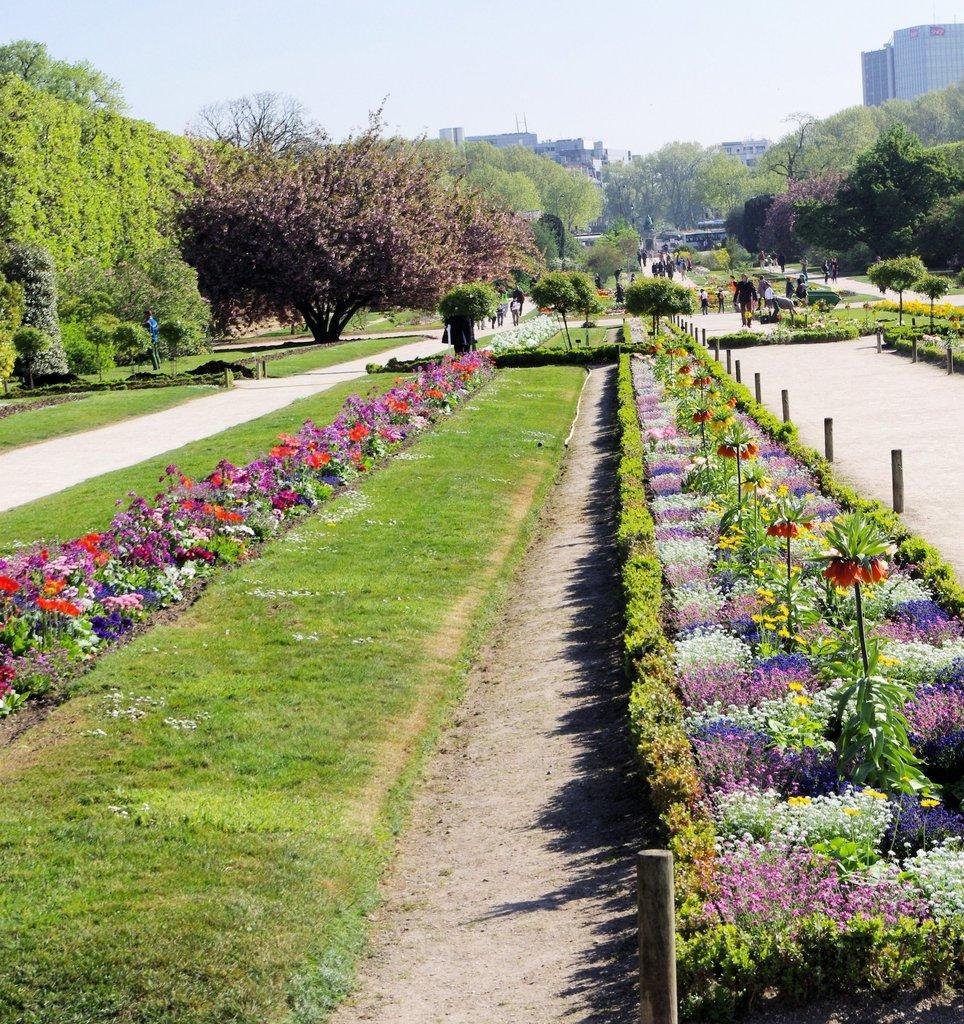In one or two sentences, can you explain what this image depicts? In this picture there are different types of flowers in the foreground. At the back there are group of people and there are buildings, trees. At the top there is sky. At the bottom there is grass and there is a road. 